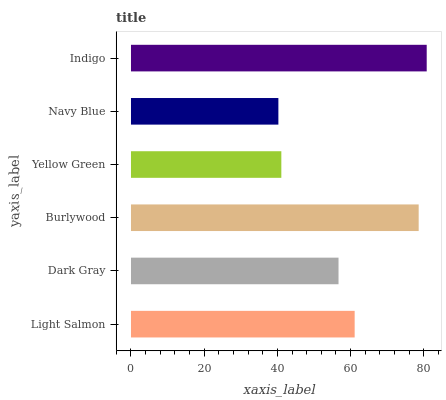Is Navy Blue the minimum?
Answer yes or no. Yes. Is Indigo the maximum?
Answer yes or no. Yes. Is Dark Gray the minimum?
Answer yes or no. No. Is Dark Gray the maximum?
Answer yes or no. No. Is Light Salmon greater than Dark Gray?
Answer yes or no. Yes. Is Dark Gray less than Light Salmon?
Answer yes or no. Yes. Is Dark Gray greater than Light Salmon?
Answer yes or no. No. Is Light Salmon less than Dark Gray?
Answer yes or no. No. Is Light Salmon the high median?
Answer yes or no. Yes. Is Dark Gray the low median?
Answer yes or no. Yes. Is Indigo the high median?
Answer yes or no. No. Is Yellow Green the low median?
Answer yes or no. No. 